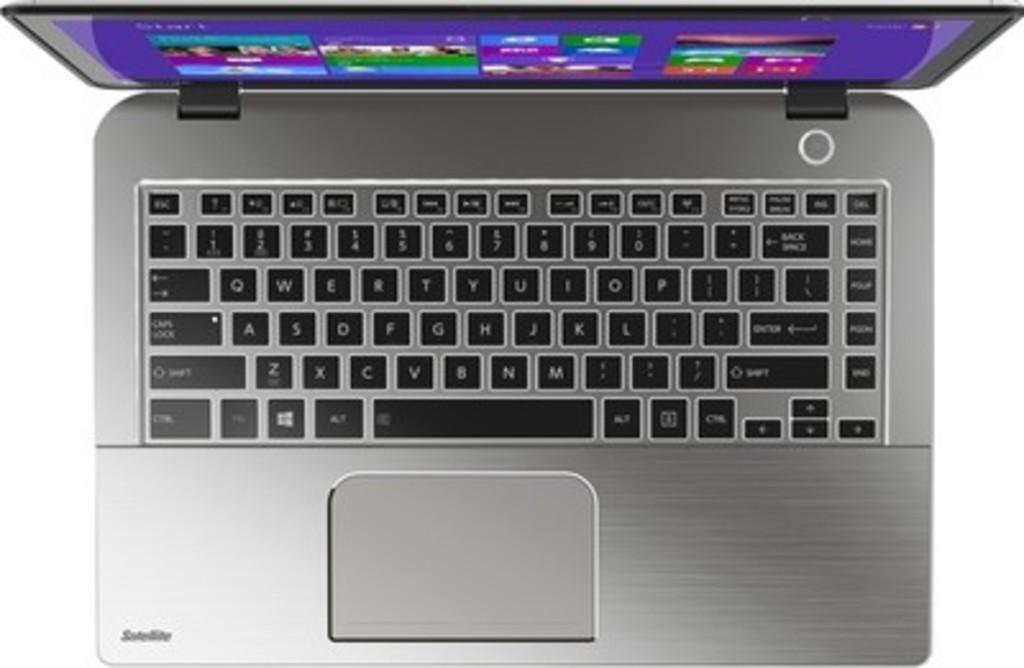Can you describe this image briefly? This image consist of a laptop. On the screen I can see some colorful images and the key buttons are in black color. 